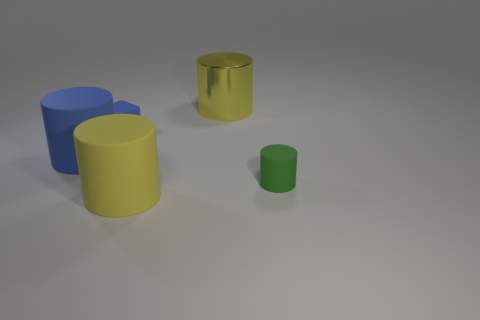Add 3 big blue matte cubes. How many objects exist? 8 Subtract all cubes. How many objects are left? 4 Add 4 small brown cubes. How many small brown cubes exist? 4 Subtract 0 brown cubes. How many objects are left? 5 Subtract all tiny green rubber objects. Subtract all big yellow rubber cylinders. How many objects are left? 3 Add 4 small green things. How many small green things are left? 5 